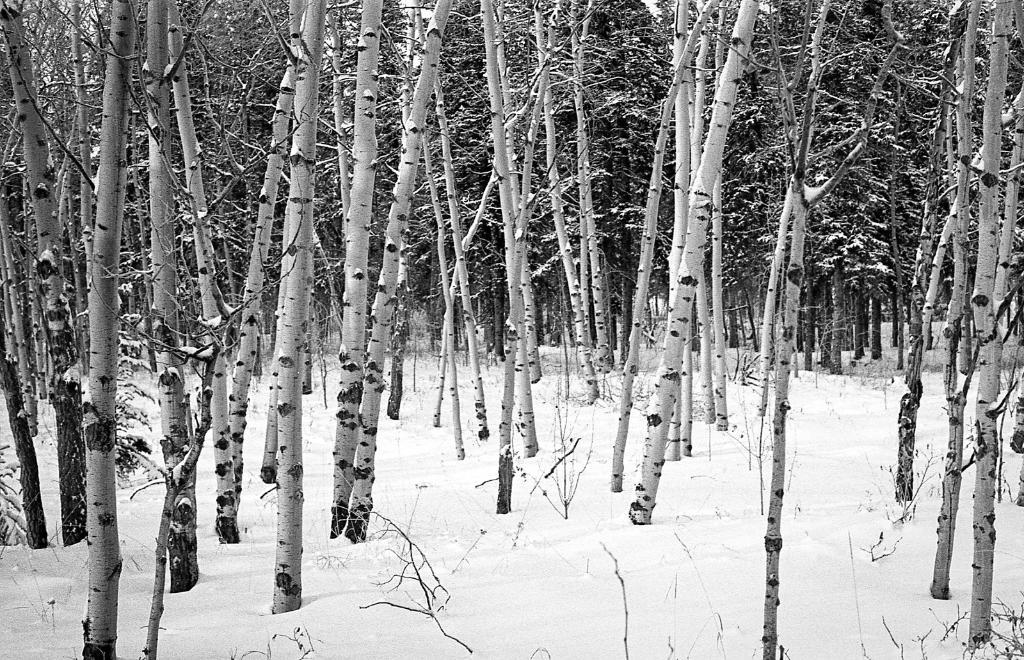What is the color scheme of the image? The image is black and white. What type of weather is depicted in the image? There is snow in the image. What natural elements can be seen in the image? There are trees in the image. Can you see any horses running through the snow in the image? There are no horses present in the image; it only features snow and trees. 